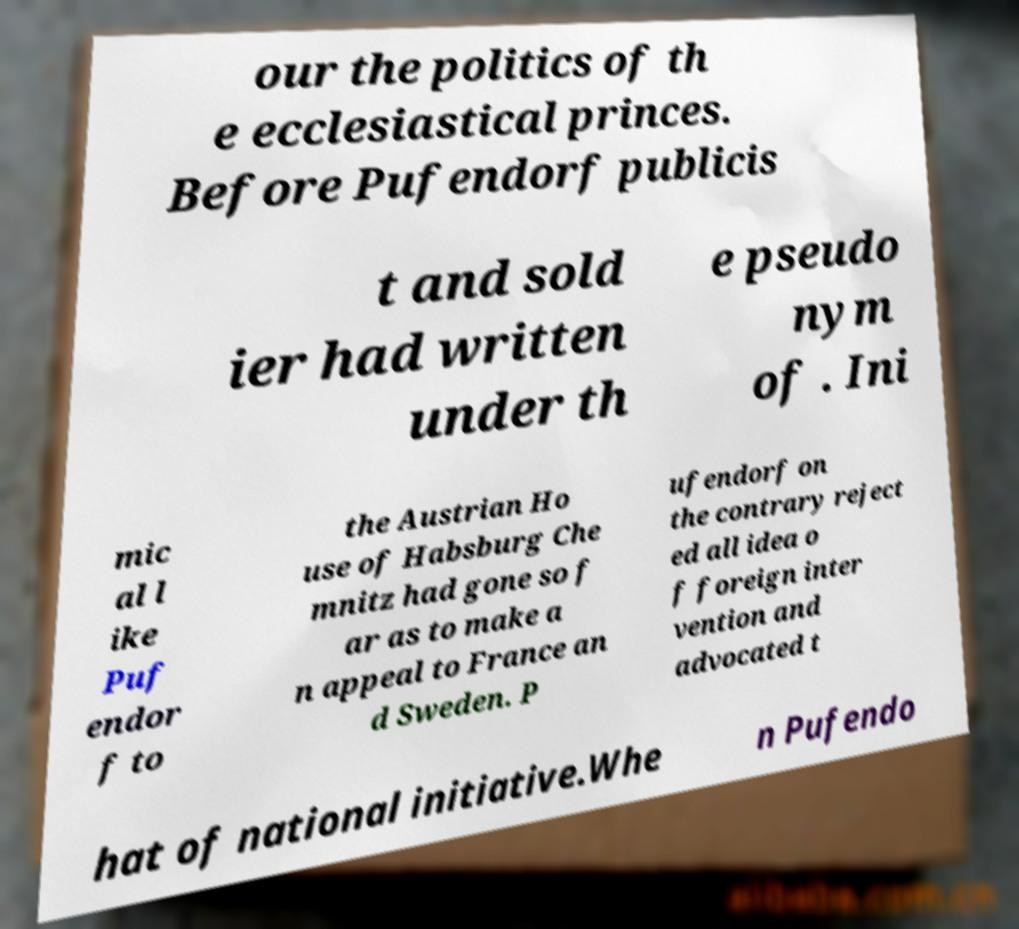I need the written content from this picture converted into text. Can you do that? our the politics of th e ecclesiastical princes. Before Pufendorf publicis t and sold ier had written under th e pseudo nym of . Ini mic al l ike Puf endor f to the Austrian Ho use of Habsburg Che mnitz had gone so f ar as to make a n appeal to France an d Sweden. P ufendorf on the contrary reject ed all idea o f foreign inter vention and advocated t hat of national initiative.Whe n Pufendo 